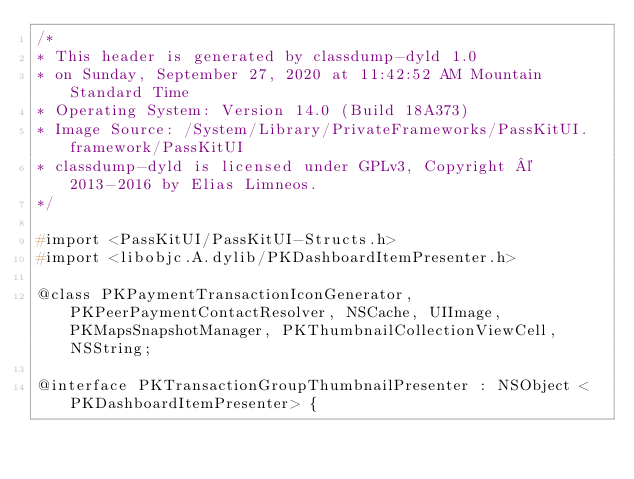Convert code to text. <code><loc_0><loc_0><loc_500><loc_500><_C_>/*
* This header is generated by classdump-dyld 1.0
* on Sunday, September 27, 2020 at 11:42:52 AM Mountain Standard Time
* Operating System: Version 14.0 (Build 18A373)
* Image Source: /System/Library/PrivateFrameworks/PassKitUI.framework/PassKitUI
* classdump-dyld is licensed under GPLv3, Copyright © 2013-2016 by Elias Limneos.
*/

#import <PassKitUI/PassKitUI-Structs.h>
#import <libobjc.A.dylib/PKDashboardItemPresenter.h>

@class PKPaymentTransactionIconGenerator, PKPeerPaymentContactResolver, NSCache, UIImage, PKMapsSnapshotManager, PKThumbnailCollectionViewCell, NSString;

@interface PKTransactionGroupThumbnailPresenter : NSObject <PKDashboardItemPresenter> {
</code> 